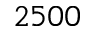<formula> <loc_0><loc_0><loc_500><loc_500>2 5 0 0</formula> 